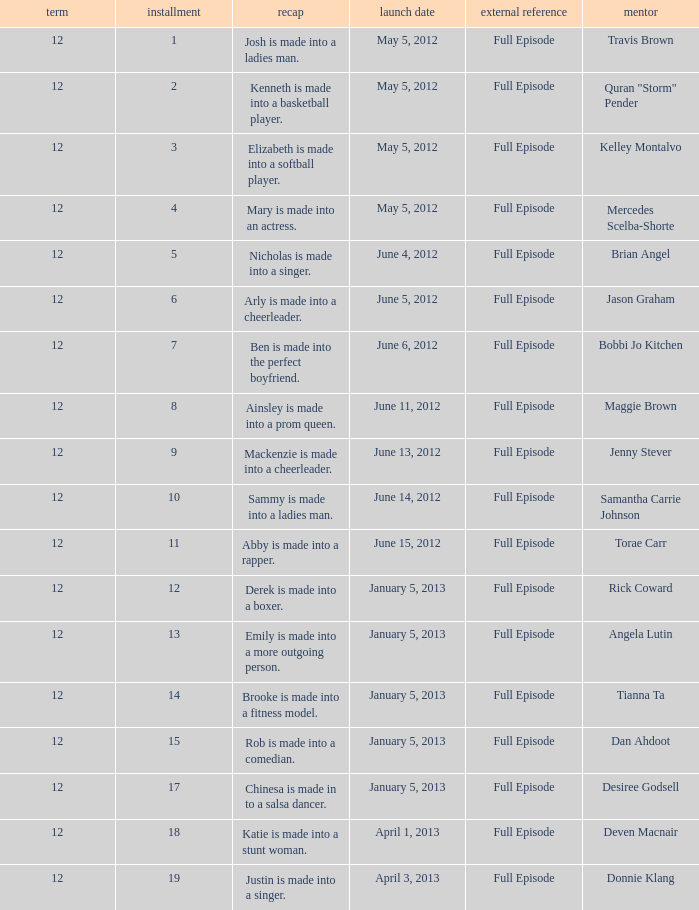Name the episode summary for travis brown Josh is made into a ladies man. 